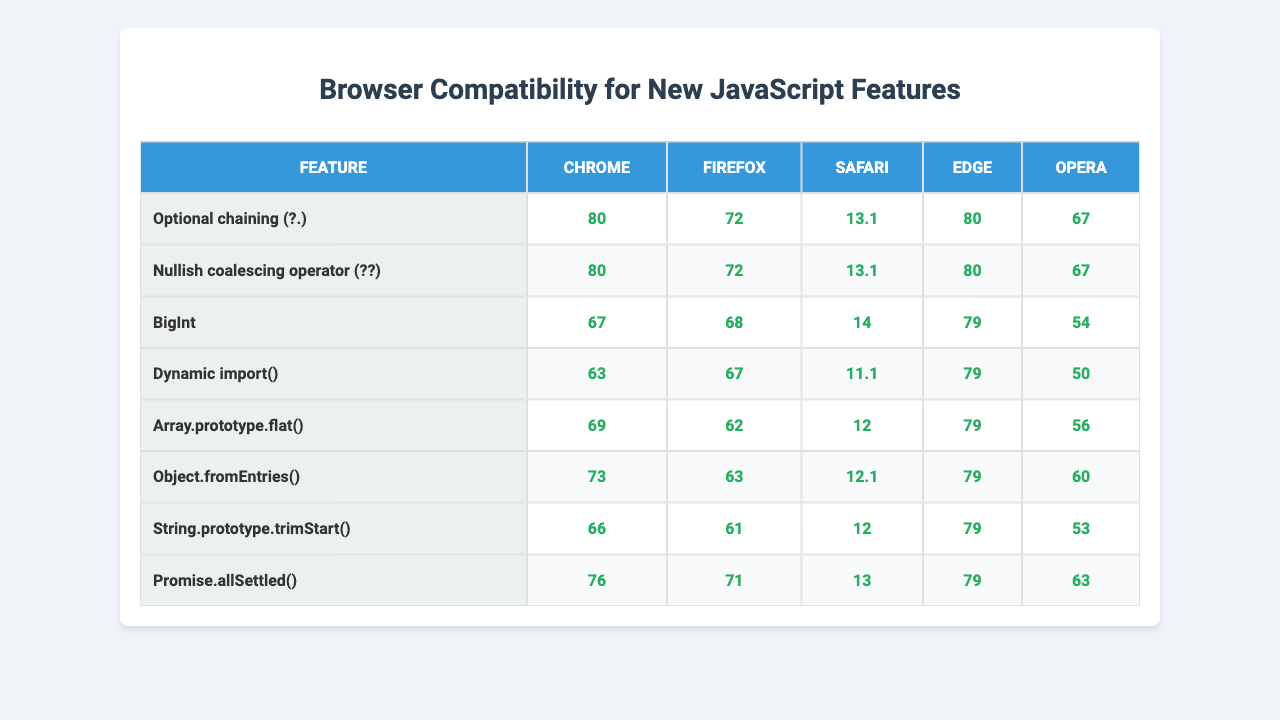What is the compatibility version for Optional Chaining in Firefox? According to the table, the compatibility version for Optional Chaining in Firefox is 72.
Answer: 72 Which feature has the earliest compatibility version in Chrome? Looking at the Chrome column, the feature BigInt has the earliest compatibility version, which is 67.
Answer: BigInt Do all browsers support the Nullish Coalescing Operator? Yes, all browsers listed in the table support the Nullish Coalescing Operator starting from version 80 or higher.
Answer: Yes Which feature is supported by the most recent version of Opera? By checking the Opera column, the most recent version for compatibility is 67 for both Optional Chaining and Nullish Coalescing Operator.
Answer: 67 (for Optional Chaining and Nullish Coalescing Operator) What's the average compatibility version across all browsers for Dynamic import()? The compatibility versions for Dynamic import() in all browsers are: Chrome 63, Firefox 67, Safari 11.1, Edge 79, and Opera 50. Summing these gives (63 + 67 + 11.1 + 79 + 50) = 270. Dividing by 5 gives an average of 54.
Answer: 54 Which feature has the lowest compatibility version across all browsers? By analyzing the compatibility versions across all features, Dynamic import() has the lowest compatibility version in Opera at 50.
Answer: Dynamic import() Is Safari the last browser to support Promise.allSettled()? No, the last browser to support Promise.allSettled() is Opera, with a version of 63, while Safari supports it starting at version 13.
Answer: No For which feature does Firefox have a lower compatibility version than Chrome? Examining the table, both features, Array.prototype.flat() and String.prototype.trimStart(), show that Firefox has lower compatibility versions than Chrome.
Answer: Array.prototype.flat() and String.prototype.trimStart() How many browsers support BigInt starting from version 68 or higher? From the compatibility table, the browsers that support BigInt starting from version 68 or higher are Chrome, Firefox, Edge, and Opera, which totals 4 browsers.
Answer: 4 What is the difference in compatibility versions for Optional Chaining between Chrome and Safari? The compatibility version for Optional Chaining in Chrome is 80 and in Safari is 13.1, so the difference is 80 - 13.1 = 66.9.
Answer: 66.9 